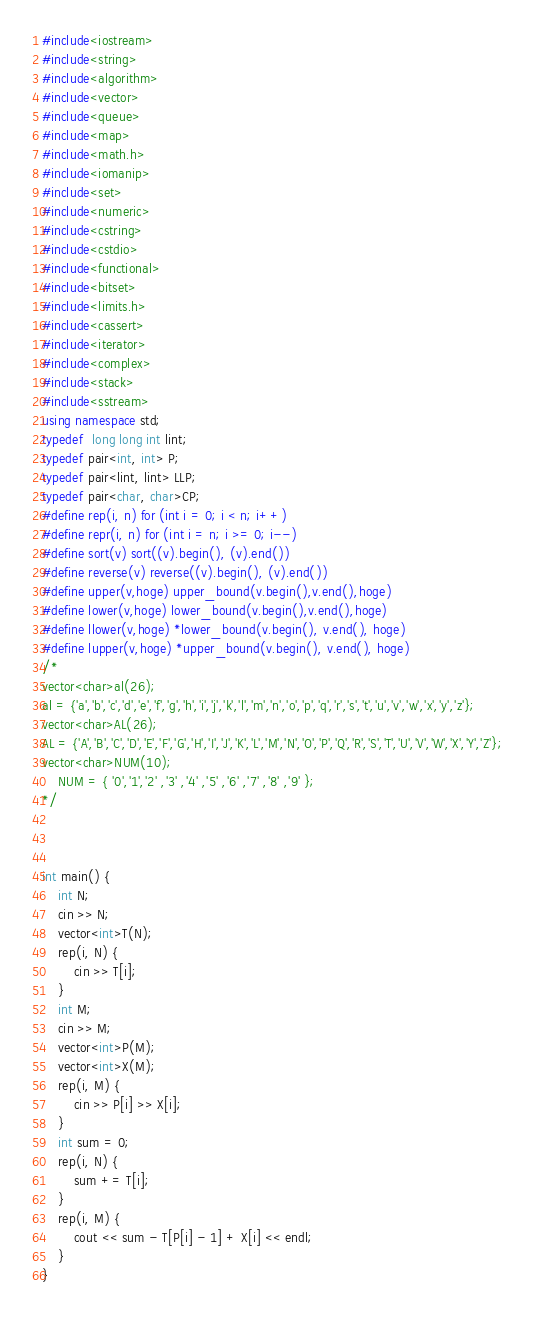<code> <loc_0><loc_0><loc_500><loc_500><_C++_>#include<iostream>
#include<string>
#include<algorithm>
#include<vector>
#include<queue>
#include<map>
#include<math.h>
#include<iomanip>
#include<set>
#include<numeric>
#include<cstring>
#include<cstdio>
#include<functional>
#include<bitset>
#include<limits.h>
#include<cassert>
#include<iterator>
#include<complex>
#include<stack>
#include<sstream>
using namespace std;
typedef  long long int lint;
typedef pair<int, int> P;
typedef pair<lint, lint> LLP;
typedef pair<char, char>CP;
#define rep(i, n) for (int i = 0; i < n; i++)
#define repr(i, n) for (int i = n; i >= 0; i--)
#define sort(v) sort((v).begin(), (v).end())
#define reverse(v) reverse((v).begin(), (v).end())
#define upper(v,hoge) upper_bound(v.begin(),v.end(),hoge)
#define lower(v,hoge) lower_bound(v.begin(),v.end(),hoge)
#define llower(v,hoge) *lower_bound(v.begin(), v.end(), hoge)
#define lupper(v,hoge) *upper_bound(v.begin(), v.end(), hoge)
/*
vector<char>al(26);
al = {'a','b','c','d','e','f','g','h','i','j','k','l','m','n','o','p','q','r','s','t','u','v','w','x','y','z'};
vector<char>AL(26);
AL = {'A','B','C','D','E','F','G','H','I','J','K','L','M','N','O','P','Q','R','S','T','U','V','W','X','Y','Z'};
vector<char>NUM(10);
	NUM = { '0','1','2' ,'3' ,'4' ,'5' ,'6' ,'7' ,'8' ,'9' };
*/



int main() {
	int N;
	cin >> N;
	vector<int>T(N);
	rep(i, N) {
		cin >> T[i];
	}
	int M;
	cin >> M;
	vector<int>P(M);
	vector<int>X(M);
	rep(i, M) {
		cin >> P[i] >> X[i];
	}
	int sum = 0;
	rep(i, N) {
		sum += T[i];
	}
	rep(i, M) {
		cout << sum - T[P[i] - 1] + X[i] << endl;
	}
}</code> 